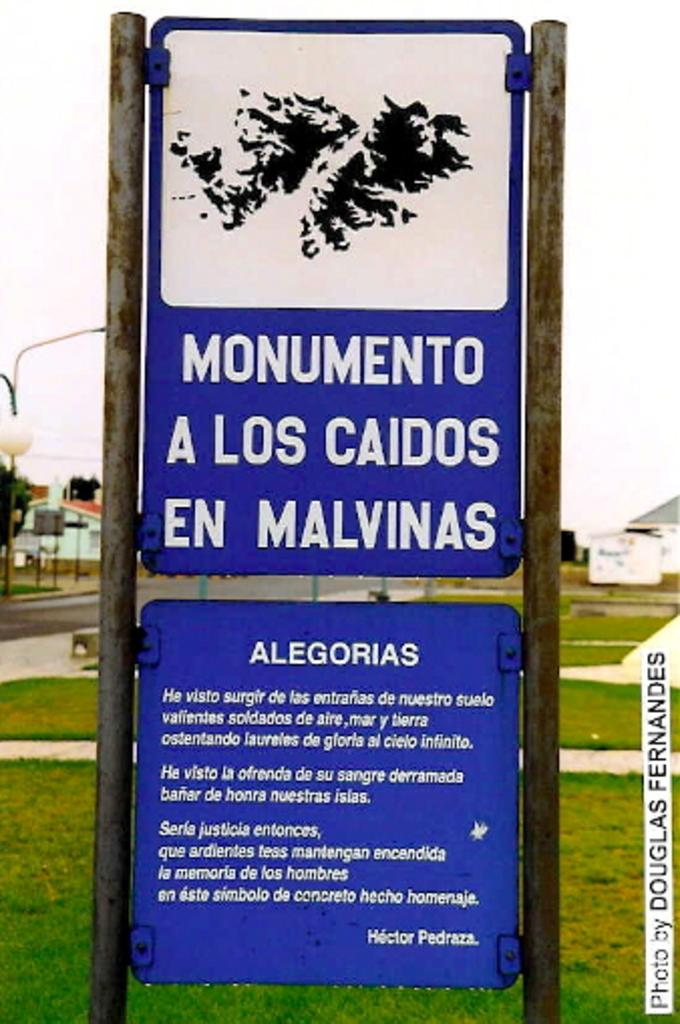What is the main object in the image? There is a board in the image. What is the purpose of the board? The board is displaying instructions. What type of environment is visible behind the board? There is a lot of grass behind the board. What structures can be seen on the left side of the image? There is a house and a street light on the left side of the image. What type of stocking is hanging from the street light in the image? There is no stocking hanging from the street light in the image. What causes the shock in the image? There is no shock or any indication of an electrical issue in the image. 